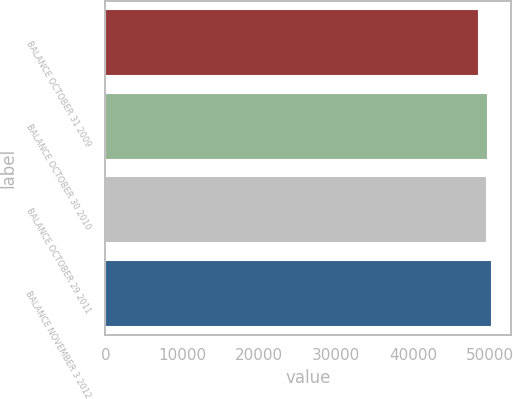Convert chart. <chart><loc_0><loc_0><loc_500><loc_500><bar_chart><fcel>BALANCE OCTOBER 31 2009<fcel>BALANCE OCTOBER 30 2010<fcel>BALANCE OCTOBER 29 2011<fcel>BALANCE NOVEMBER 3 2012<nl><fcel>48645<fcel>49819.8<fcel>49661<fcel>50233<nl></chart> 